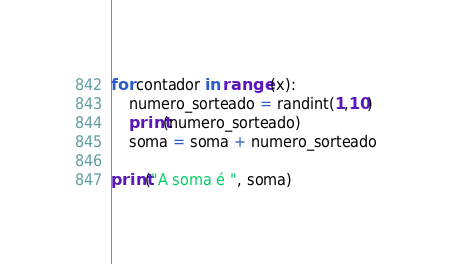Convert code to text. <code><loc_0><loc_0><loc_500><loc_500><_Python_>for contador in range (x):
    numero_sorteado = randint(1,10)
    print(numero_sorteado)
    soma = soma + numero_sorteado

print("A soma é ", soma)
</code> 